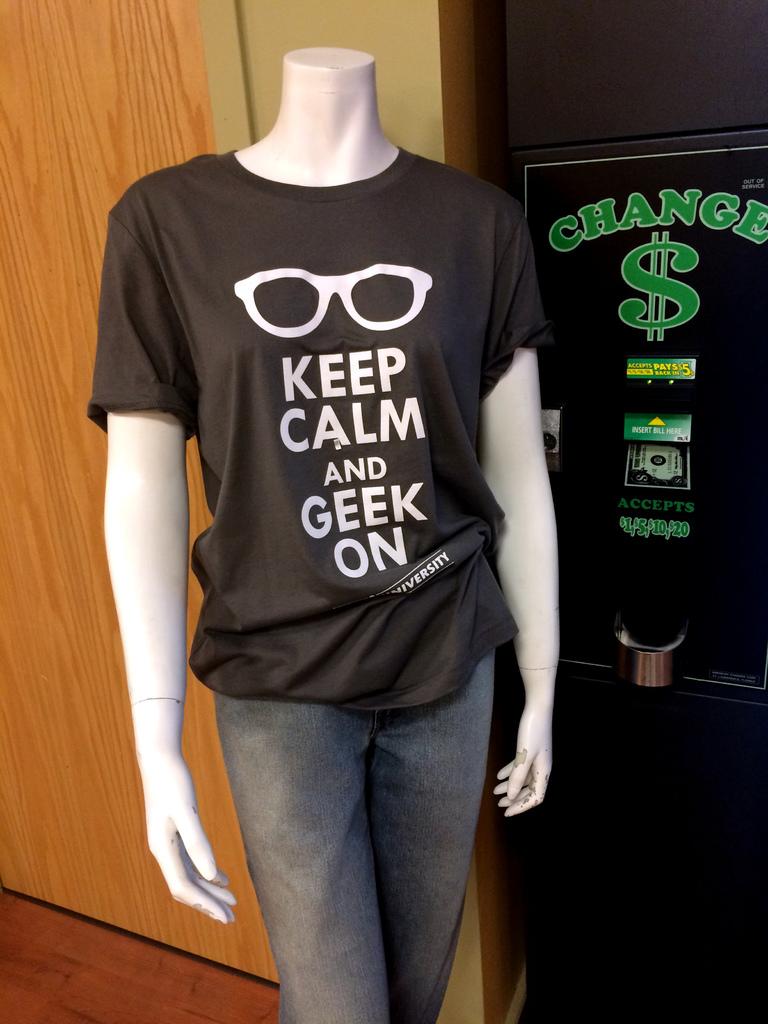According to this shirt what action should be performed?
Your answer should be compact. Keep calm and geek on. What is the top word written in green say?
Your response must be concise. Change. 